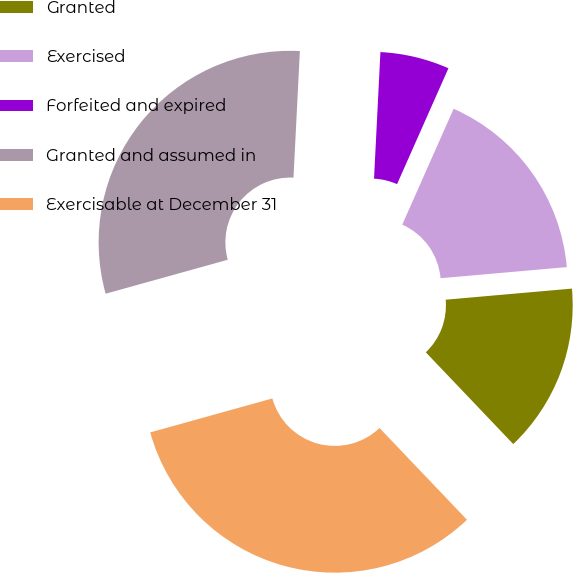Convert chart to OTSL. <chart><loc_0><loc_0><loc_500><loc_500><pie_chart><fcel>Granted<fcel>Exercised<fcel>Forfeited and expired<fcel>Granted and assumed in<fcel>Exercisable at December 31<nl><fcel>14.28%<fcel>16.96%<fcel>5.84%<fcel>30.12%<fcel>32.8%<nl></chart> 